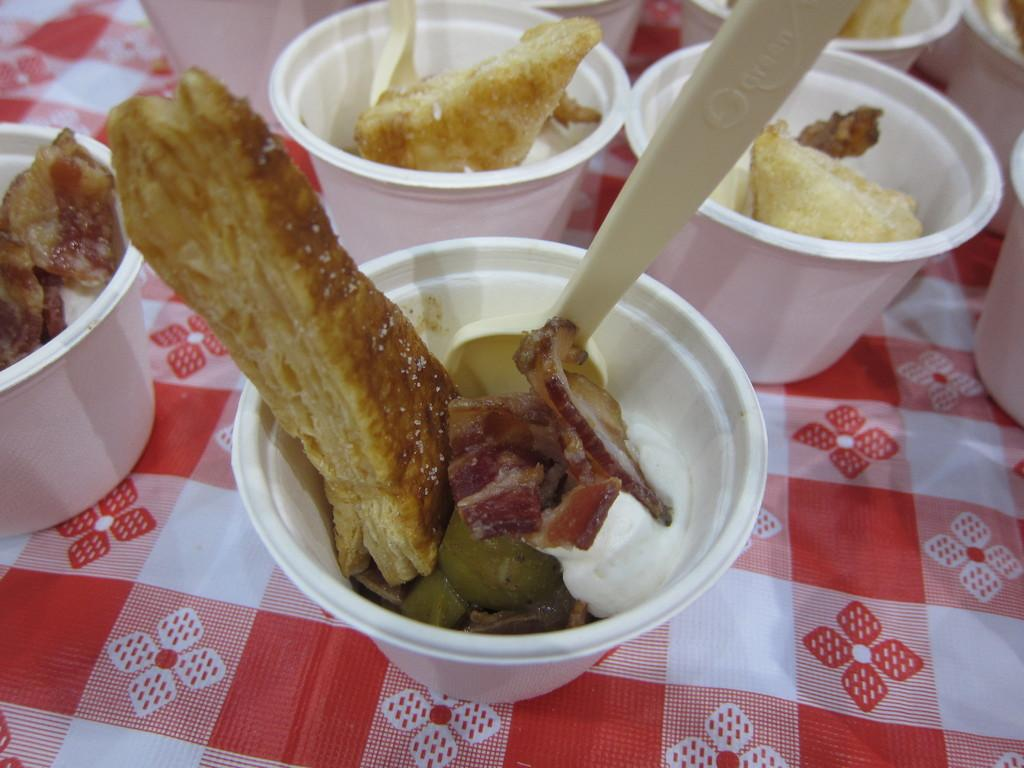What is inside the glasses in the image? There is food in the glasses in the image. What is placed beneath the glasses in the image? There is a cloth below the glasses in the image. Can you identify any utensils in the image? Yes, there is a spoon in the image. What flavor of tank can be seen in the image? There is no tank present in the image, and therefore no flavor can be associated with it. 